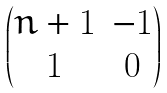Convert formula to latex. <formula><loc_0><loc_0><loc_500><loc_500>\begin{pmatrix} n + 1 & - 1 \\ 1 & 0 \end{pmatrix}</formula> 